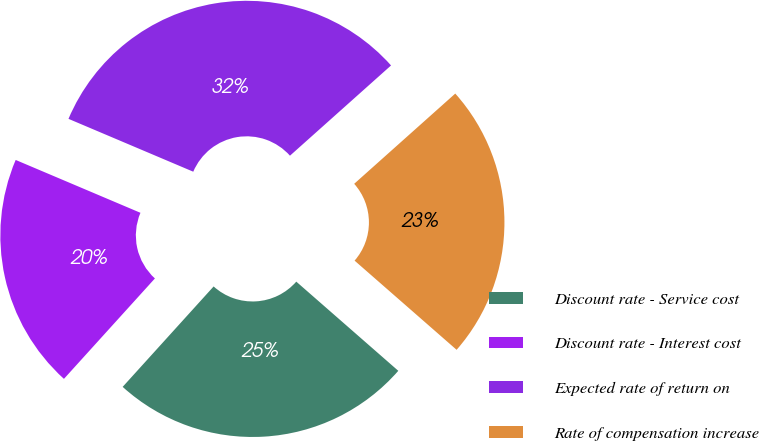<chart> <loc_0><loc_0><loc_500><loc_500><pie_chart><fcel>Discount rate - Service cost<fcel>Discount rate - Interest cost<fcel>Expected rate of return on<fcel>Rate of compensation increase<nl><fcel>25.28%<fcel>19.66%<fcel>32.02%<fcel>23.03%<nl></chart> 